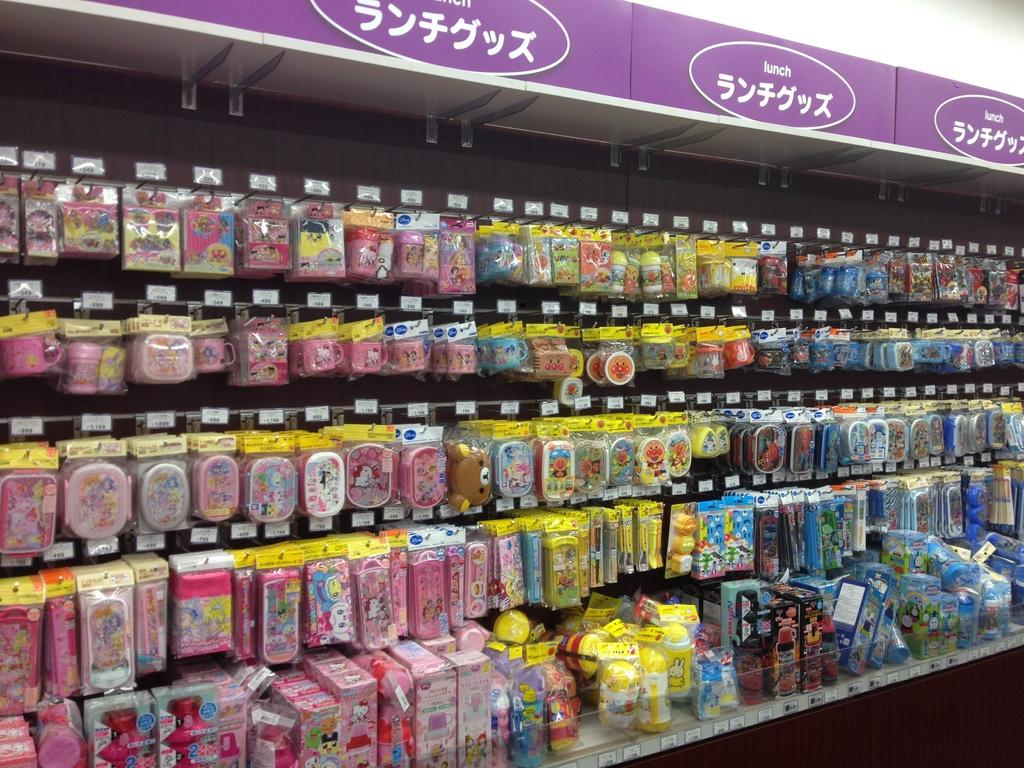What is present in the image that can hold objects? There is a rack in the image that can hold objects. What can be observed about the objects on the rack? Objects are hanged on the rack. What is the color of the board in the image? The board in the image is purple. What is the color of the wall in the image? The wall in the image is white. What part of the wall is visible in the image? The top of the image shows the white wall. What type of education is being provided in the image? There is no indication of education being provided in the image. What color is the shade in the image? There is no shade present in the image. 